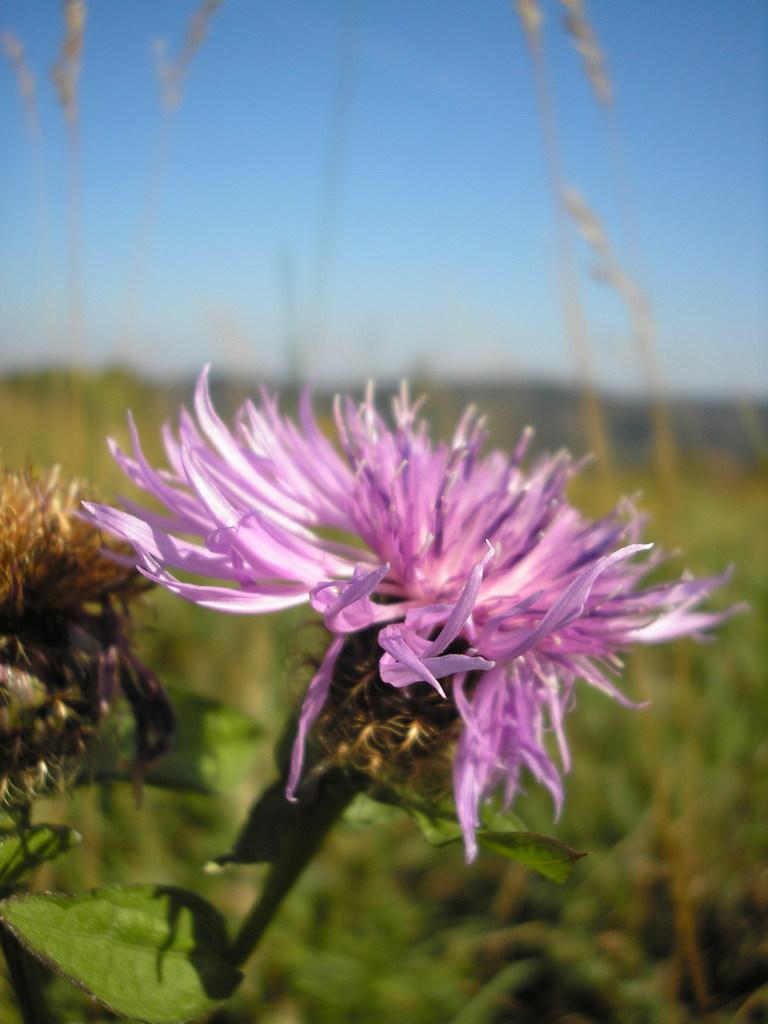What is located in the front of the image? There are flowers in the front of the image. Can you describe the background of the image? The background of the image is blurry. What color crayon is the stranger using to say good-bye in the image? There is no stranger or crayon present in the image, so it is not possible to answer that question. 